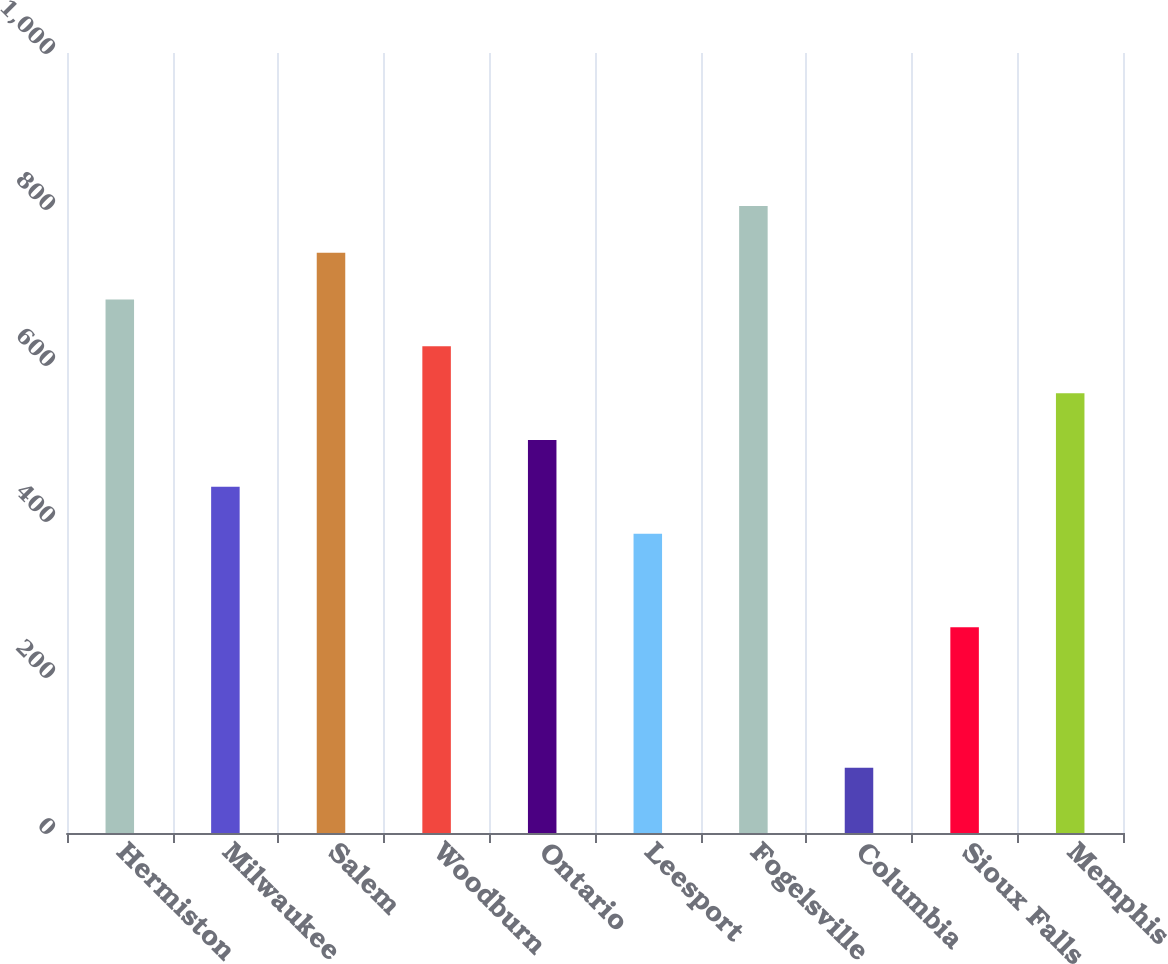<chart> <loc_0><loc_0><loc_500><loc_500><bar_chart><fcel>Hermiston<fcel>Milwaukee<fcel>Salem<fcel>Woodburn<fcel>Ontario<fcel>Leesport<fcel>Fogelsville<fcel>Columbia<fcel>Sioux Falls<fcel>Memphis<nl><fcel>683.9<fcel>443.82<fcel>743.92<fcel>623.88<fcel>503.84<fcel>383.8<fcel>803.94<fcel>83.7<fcel>263.76<fcel>563.86<nl></chart> 